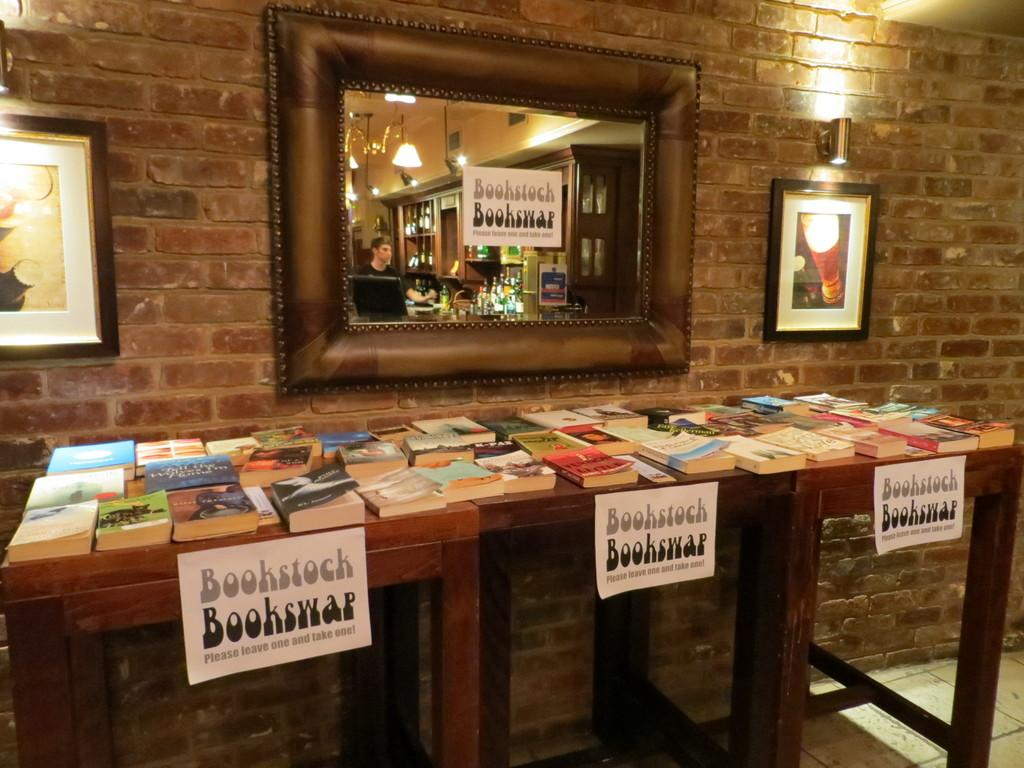What is the main piece of furniture in the image? There is a table in the image. What items can be seen on the table? There are books on the table. What can be seen in the background of the image? There is a wall in the background of the image. What decorative items are on the wall? There is a mirror, photo frames, and lights on the wall. What suggestion does the brain make in the image? There is no brain or suggestion present in the image. 